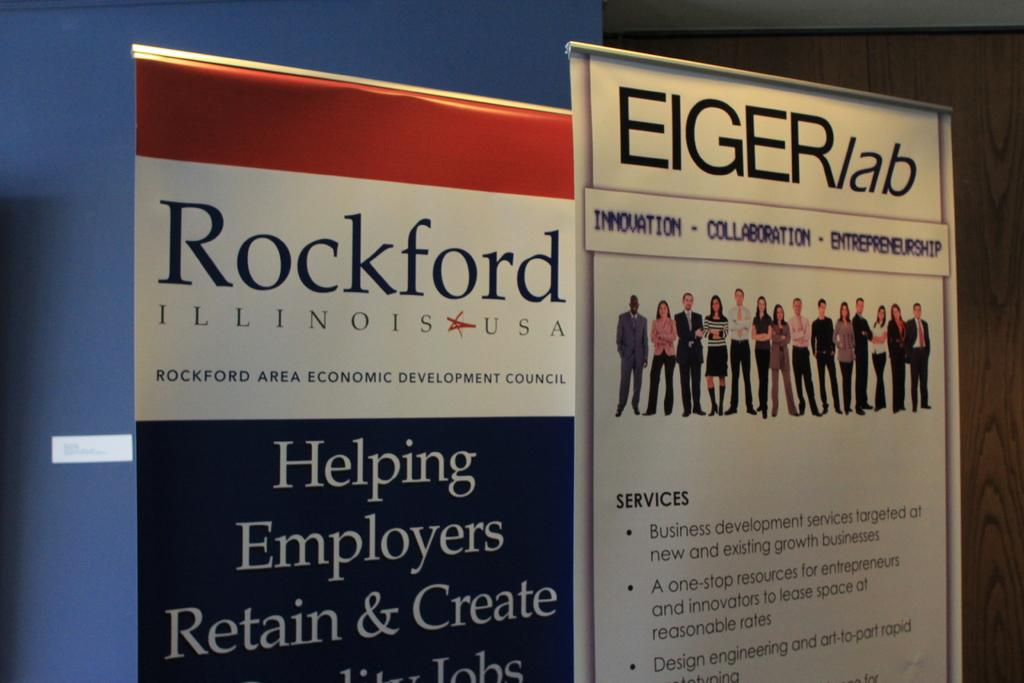<image>
Offer a succinct explanation of the picture presented. A sign for Rockford Illinois sits next to an Eiger lab sign. 